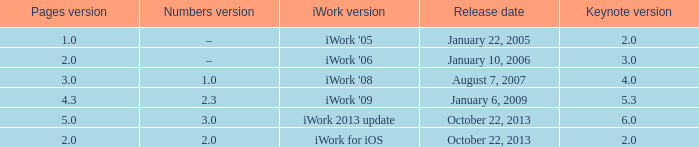What's the latest keynote version of version 2.3 of numbers with pages greater than 4.3? None. 